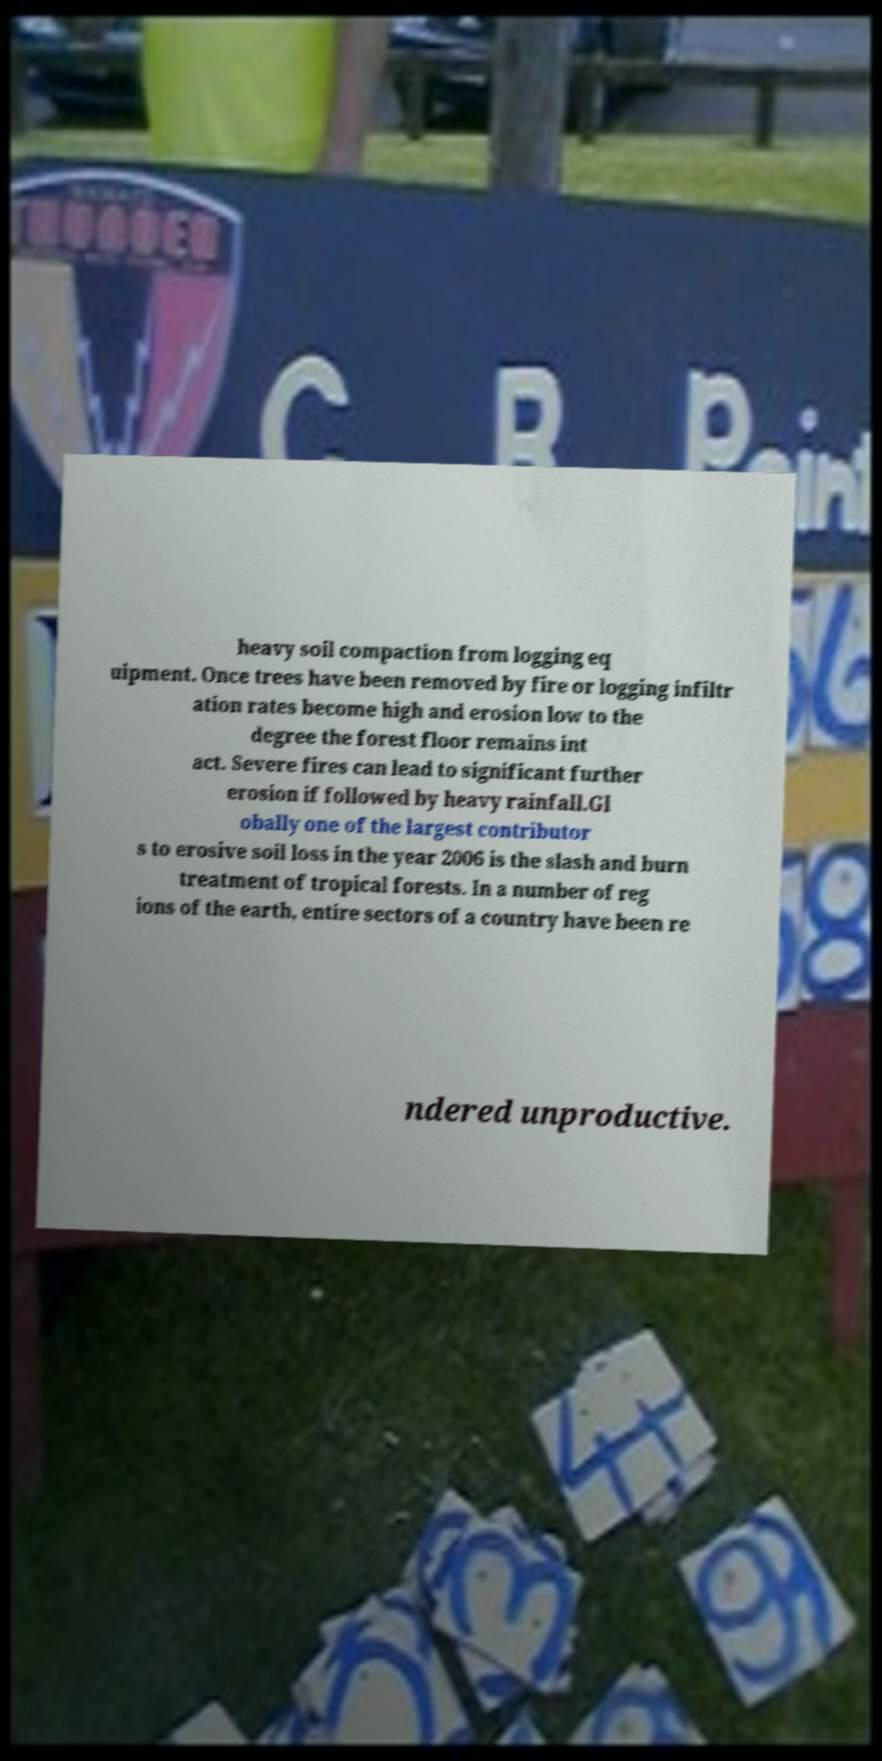For documentation purposes, I need the text within this image transcribed. Could you provide that? heavy soil compaction from logging eq uipment. Once trees have been removed by fire or logging infiltr ation rates become high and erosion low to the degree the forest floor remains int act. Severe fires can lead to significant further erosion if followed by heavy rainfall.Gl obally one of the largest contributor s to erosive soil loss in the year 2006 is the slash and burn treatment of tropical forests. In a number of reg ions of the earth, entire sectors of a country have been re ndered unproductive. 